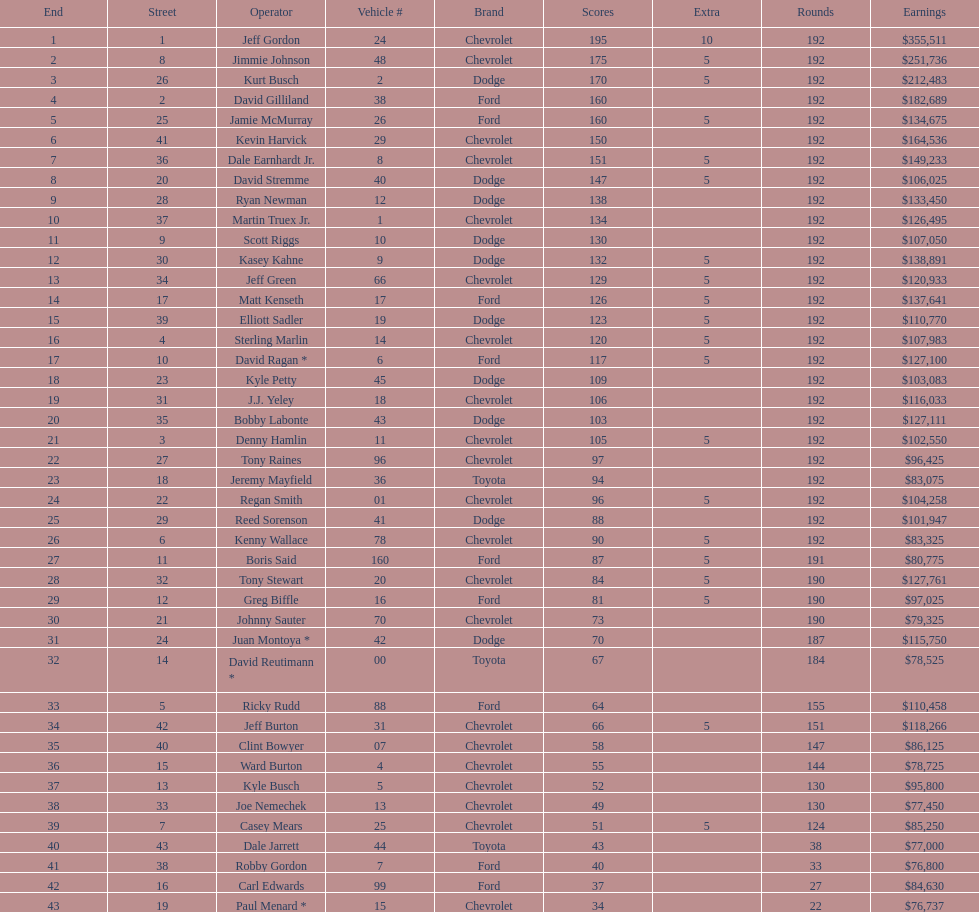What driver earned the least amount of winnings? Paul Menard *. 